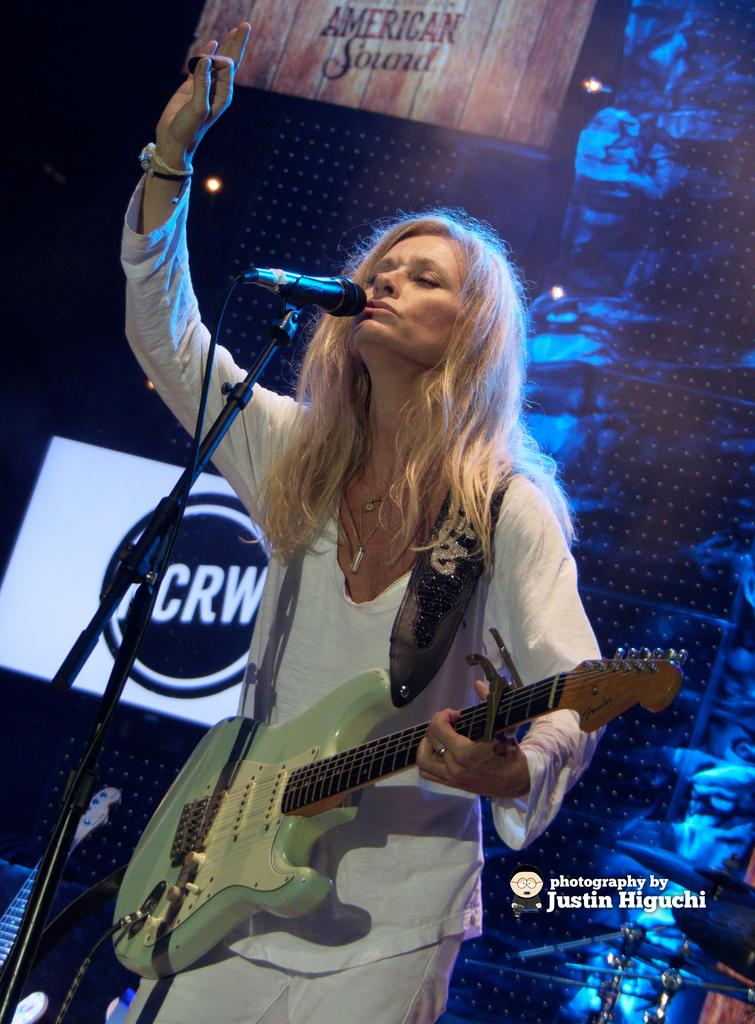Who is the main subject in the image? There is a woman in the image. What is the woman holding in the image? The woman is holding a guitar. What object is in front of the woman? There is a microphone in front of the woman. What can be seen in the background of the image? There are posters in the background of the image. What design is featured on the caption of the image? There is no caption present in the image, so it is not possible to determine the design. 